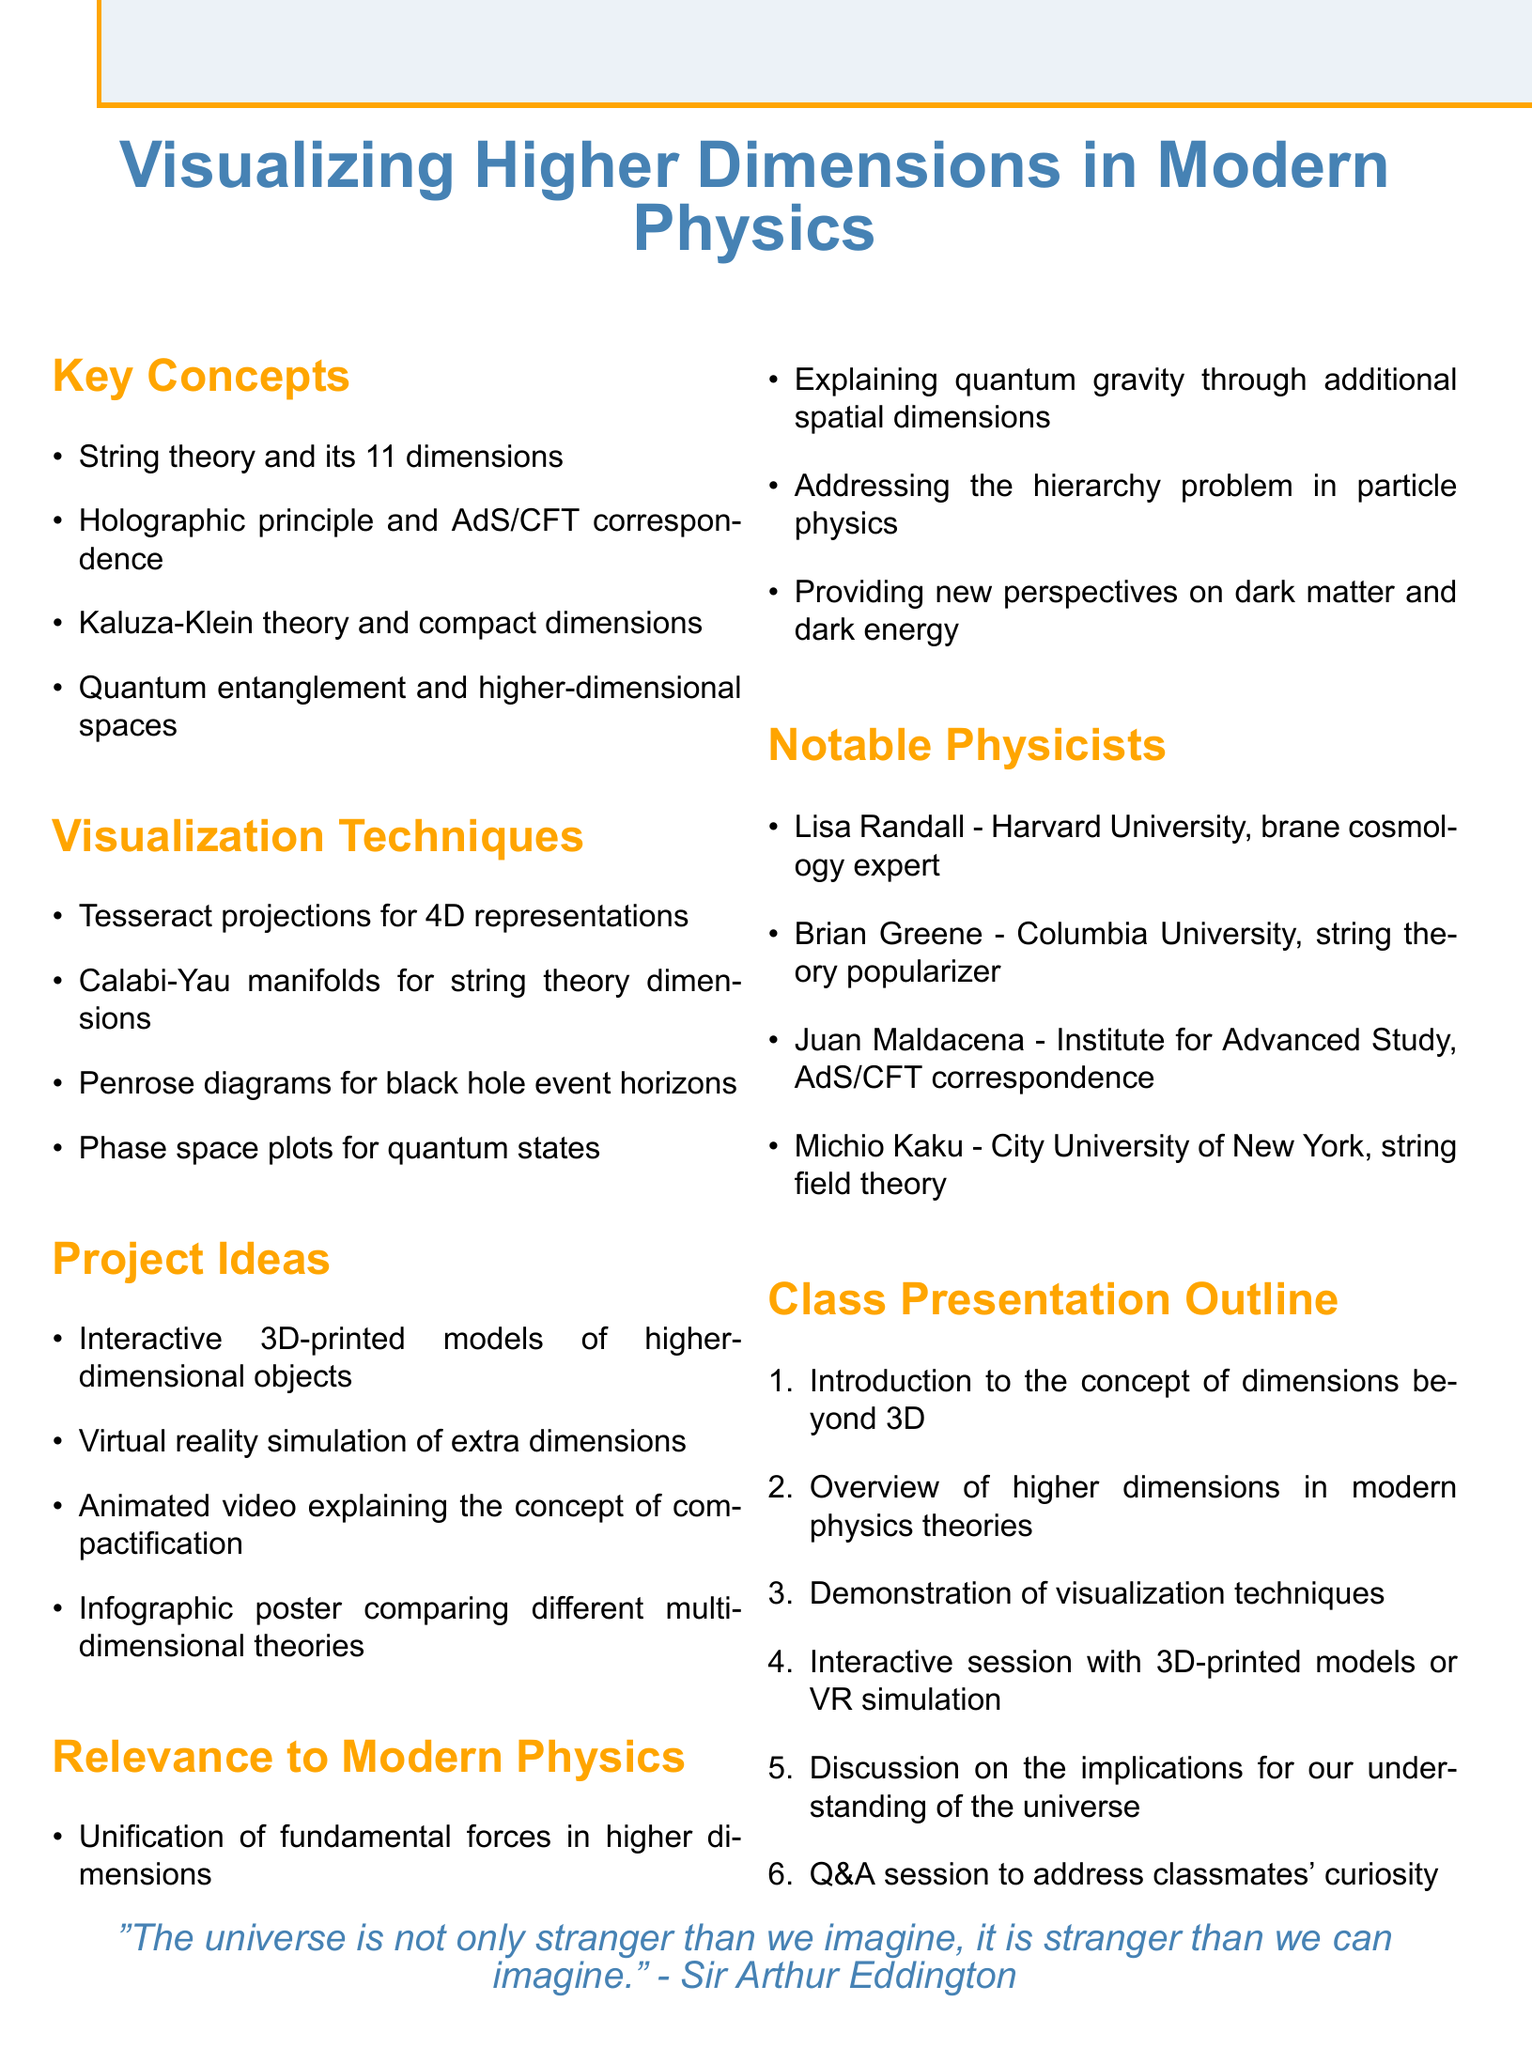What is the title of the document? The title is clearly stated at the beginning of the document.
Answer: Visualizing Higher Dimensions in Modern Physics How many dimensions are proposed in String theory? The document specifically mentions the number of dimensions in the context of string theory.
Answer: 11 dimensions What is one technique used for visualizing higher dimensions? The document lists various visualization techniques applicable to higher dimensions.
Answer: Tesseract projections Name one notable physicist mentioned. The document includes a section listing notable physicists in the field.
Answer: Lisa Randall What project involves virtual reality simulation? The document lists various project ideas, one of which includes using virtual reality.
Answer: Virtual reality simulation of extra dimensions What is the relevance of higher dimensions in quantum gravity? The document summarizes the relevance of higher dimensions to modern physics theories, including quantum gravity.
Answer: Explaining quantum gravity through additional spatial dimensions What is the focus of the interactive session mentioned in the outline? The class presentation outline describes the focus of the interactive session.
Answer: 3D-printed models or VR simulation Which concept addresses the hierarchy problem in particle physics? The document highlights relevance to current problems in physics theories, including the hierarchy problem.
Answer: Unification of fundamental forces in higher dimensions 